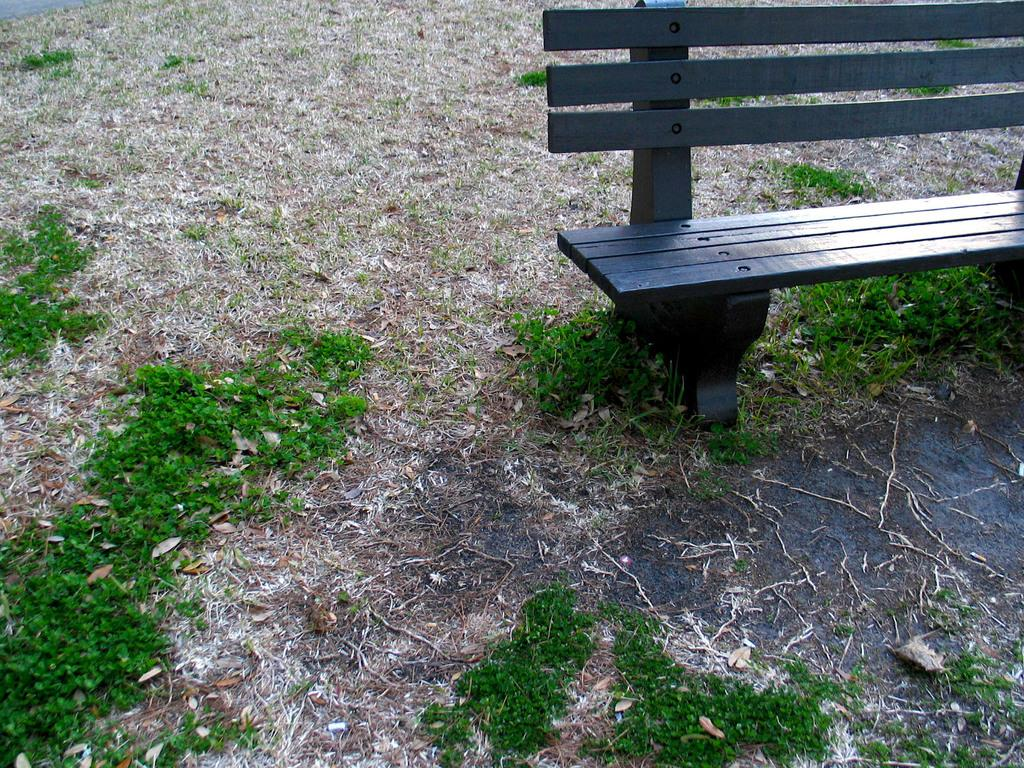What is the main object in the center of the image? There is a bench in the center of the image. What type of surface is at the bottom of the image? There is grass and a road at the bottom of the image. How many stars can be seen hanging from the bench in the image? There are no stars present in the image; it features a bench, grass, and a road. 